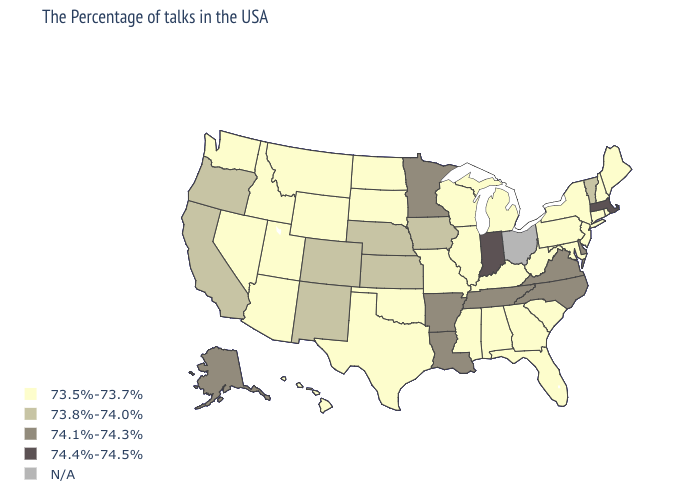Name the states that have a value in the range 74.1%-74.3%?
Answer briefly. Delaware, Virginia, North Carolina, Tennessee, Louisiana, Arkansas, Minnesota, Alaska. What is the value of Colorado?
Write a very short answer. 73.8%-74.0%. What is the highest value in the Northeast ?
Give a very brief answer. 74.4%-74.5%. Is the legend a continuous bar?
Keep it brief. No. What is the lowest value in the USA?
Answer briefly. 73.5%-73.7%. Does Alaska have the highest value in the West?
Give a very brief answer. Yes. Is the legend a continuous bar?
Give a very brief answer. No. Among the states that border Arizona , does Utah have the highest value?
Quick response, please. No. What is the lowest value in the Northeast?
Keep it brief. 73.5%-73.7%. Among the states that border Iowa , does Minnesota have the highest value?
Be succinct. Yes. Name the states that have a value in the range 73.5%-73.7%?
Be succinct. Maine, Rhode Island, New Hampshire, Connecticut, New York, New Jersey, Maryland, Pennsylvania, South Carolina, West Virginia, Florida, Georgia, Michigan, Kentucky, Alabama, Wisconsin, Illinois, Mississippi, Missouri, Oklahoma, Texas, South Dakota, North Dakota, Wyoming, Utah, Montana, Arizona, Idaho, Nevada, Washington, Hawaii. Among the states that border Montana , which have the highest value?
Give a very brief answer. South Dakota, North Dakota, Wyoming, Idaho. 